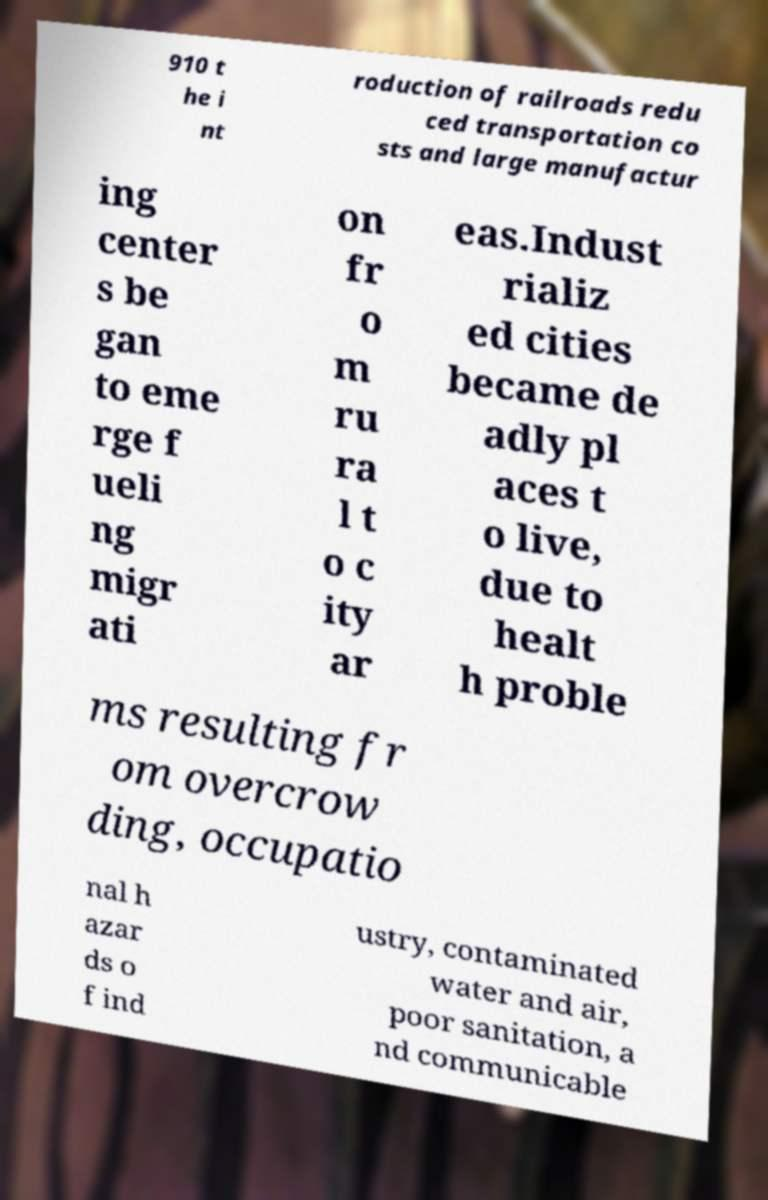Could you extract and type out the text from this image? 910 t he i nt roduction of railroads redu ced transportation co sts and large manufactur ing center s be gan to eme rge f ueli ng migr ati on fr o m ru ra l t o c ity ar eas.Indust rializ ed cities became de adly pl aces t o live, due to healt h proble ms resulting fr om overcrow ding, occupatio nal h azar ds o f ind ustry, contaminated water and air, poor sanitation, a nd communicable 